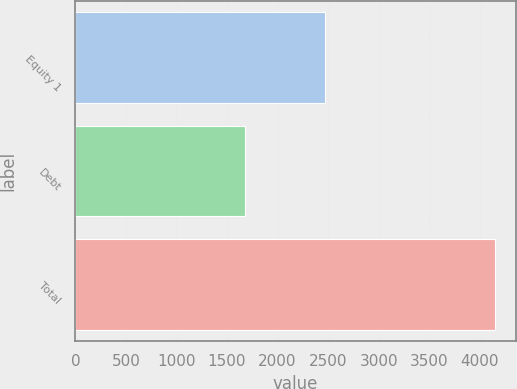Convert chart to OTSL. <chart><loc_0><loc_0><loc_500><loc_500><bar_chart><fcel>Equity 1<fcel>Debt<fcel>Total<nl><fcel>2471<fcel>1676<fcel>4147<nl></chart> 